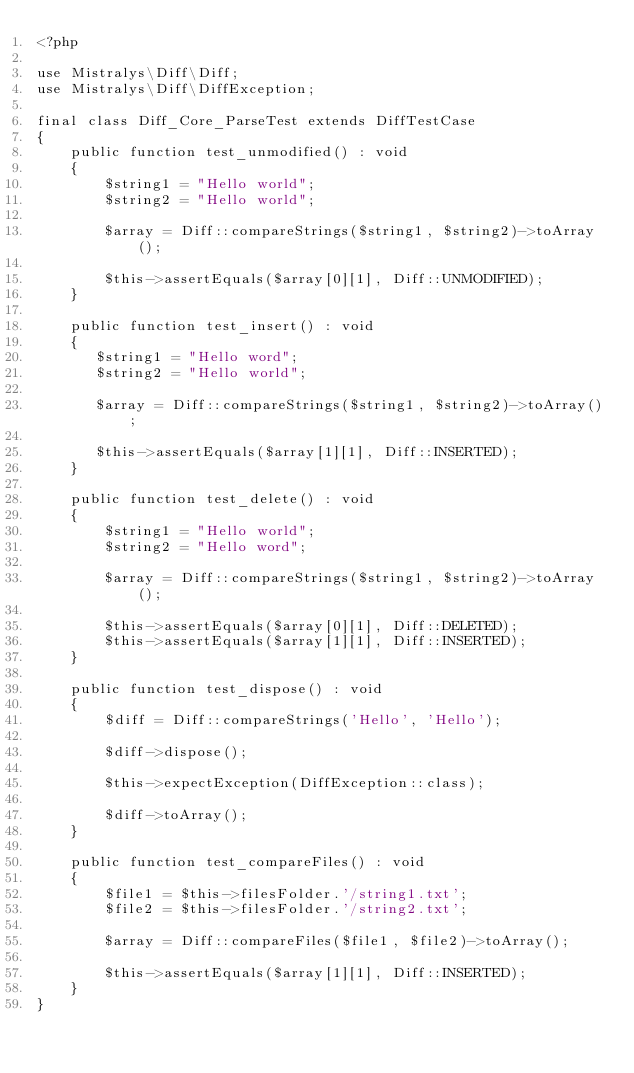<code> <loc_0><loc_0><loc_500><loc_500><_PHP_><?php

use Mistralys\Diff\Diff;
use Mistralys\Diff\DiffException;

final class Diff_Core_ParseTest extends DiffTestCase
{
    public function test_unmodified() : void
    {
        $string1 = "Hello world";
        $string2 = "Hello world";
        
        $array = Diff::compareStrings($string1, $string2)->toArray();
        
        $this->assertEquals($array[0][1], Diff::UNMODIFIED);
    }
    
    public function test_insert() : void
    {
       $string1 = "Hello word";
       $string2 = "Hello world";
       
       $array = Diff::compareStrings($string1, $string2)->toArray();

       $this->assertEquals($array[1][1], Diff::INSERTED);
    }

    public function test_delete() : void
    {
        $string1 = "Hello world";
        $string2 = "Hello word";
        
        $array = Diff::compareStrings($string1, $string2)->toArray();

        $this->assertEquals($array[0][1], Diff::DELETED);
        $this->assertEquals($array[1][1], Diff::INSERTED);
    }
    
    public function test_dispose() : void
    {
        $diff = Diff::compareStrings('Hello', 'Hello');
        
        $diff->dispose();
        
        $this->expectException(DiffException::class);
        
        $diff->toArray();
    }
    
    public function test_compareFiles() : void
    {
        $file1 = $this->filesFolder.'/string1.txt';
        $file2 = $this->filesFolder.'/string2.txt';
        
        $array = Diff::compareFiles($file1, $file2)->toArray();
        
        $this->assertEquals($array[1][1], Diff::INSERTED);
    }
}
</code> 